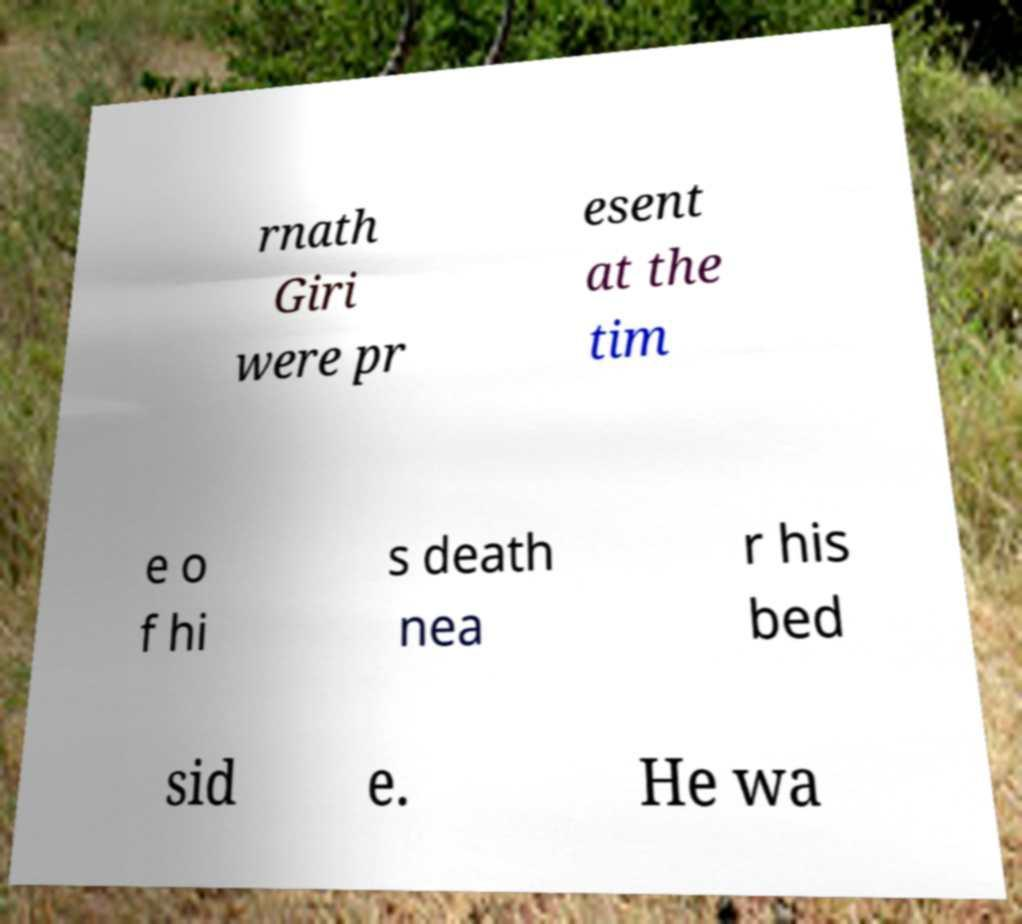Can you read and provide the text displayed in the image?This photo seems to have some interesting text. Can you extract and type it out for me? rnath Giri were pr esent at the tim e o f hi s death nea r his bed sid e. He wa 